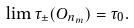<formula> <loc_0><loc_0><loc_500><loc_500>\lim \tau _ { \pm } ( O _ { n _ { m } } ) = \tau _ { 0 } .</formula> 